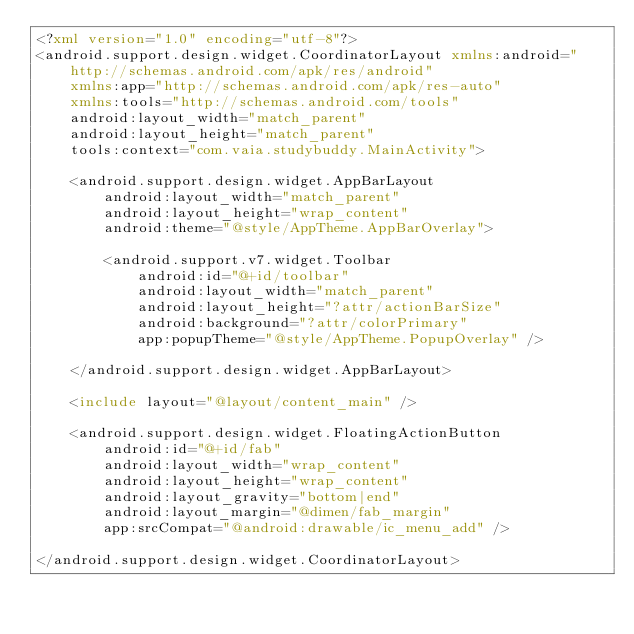Convert code to text. <code><loc_0><loc_0><loc_500><loc_500><_XML_><?xml version="1.0" encoding="utf-8"?>
<android.support.design.widget.CoordinatorLayout xmlns:android="http://schemas.android.com/apk/res/android"
    xmlns:app="http://schemas.android.com/apk/res-auto"
    xmlns:tools="http://schemas.android.com/tools"
    android:layout_width="match_parent"
    android:layout_height="match_parent"
    tools:context="com.vaia.studybuddy.MainActivity">

    <android.support.design.widget.AppBarLayout
        android:layout_width="match_parent"
        android:layout_height="wrap_content"
        android:theme="@style/AppTheme.AppBarOverlay">

        <android.support.v7.widget.Toolbar
            android:id="@+id/toolbar"
            android:layout_width="match_parent"
            android:layout_height="?attr/actionBarSize"
            android:background="?attr/colorPrimary"
            app:popupTheme="@style/AppTheme.PopupOverlay" />

    </android.support.design.widget.AppBarLayout>

    <include layout="@layout/content_main" />

    <android.support.design.widget.FloatingActionButton
        android:id="@+id/fab"
        android:layout_width="wrap_content"
        android:layout_height="wrap_content"
        android:layout_gravity="bottom|end"
        android:layout_margin="@dimen/fab_margin"
        app:srcCompat="@android:drawable/ic_menu_add" />

</android.support.design.widget.CoordinatorLayout>
</code> 